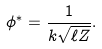<formula> <loc_0><loc_0><loc_500><loc_500>\phi ^ { * } = \frac { 1 } { k \sqrt { \ell Z } } .</formula> 